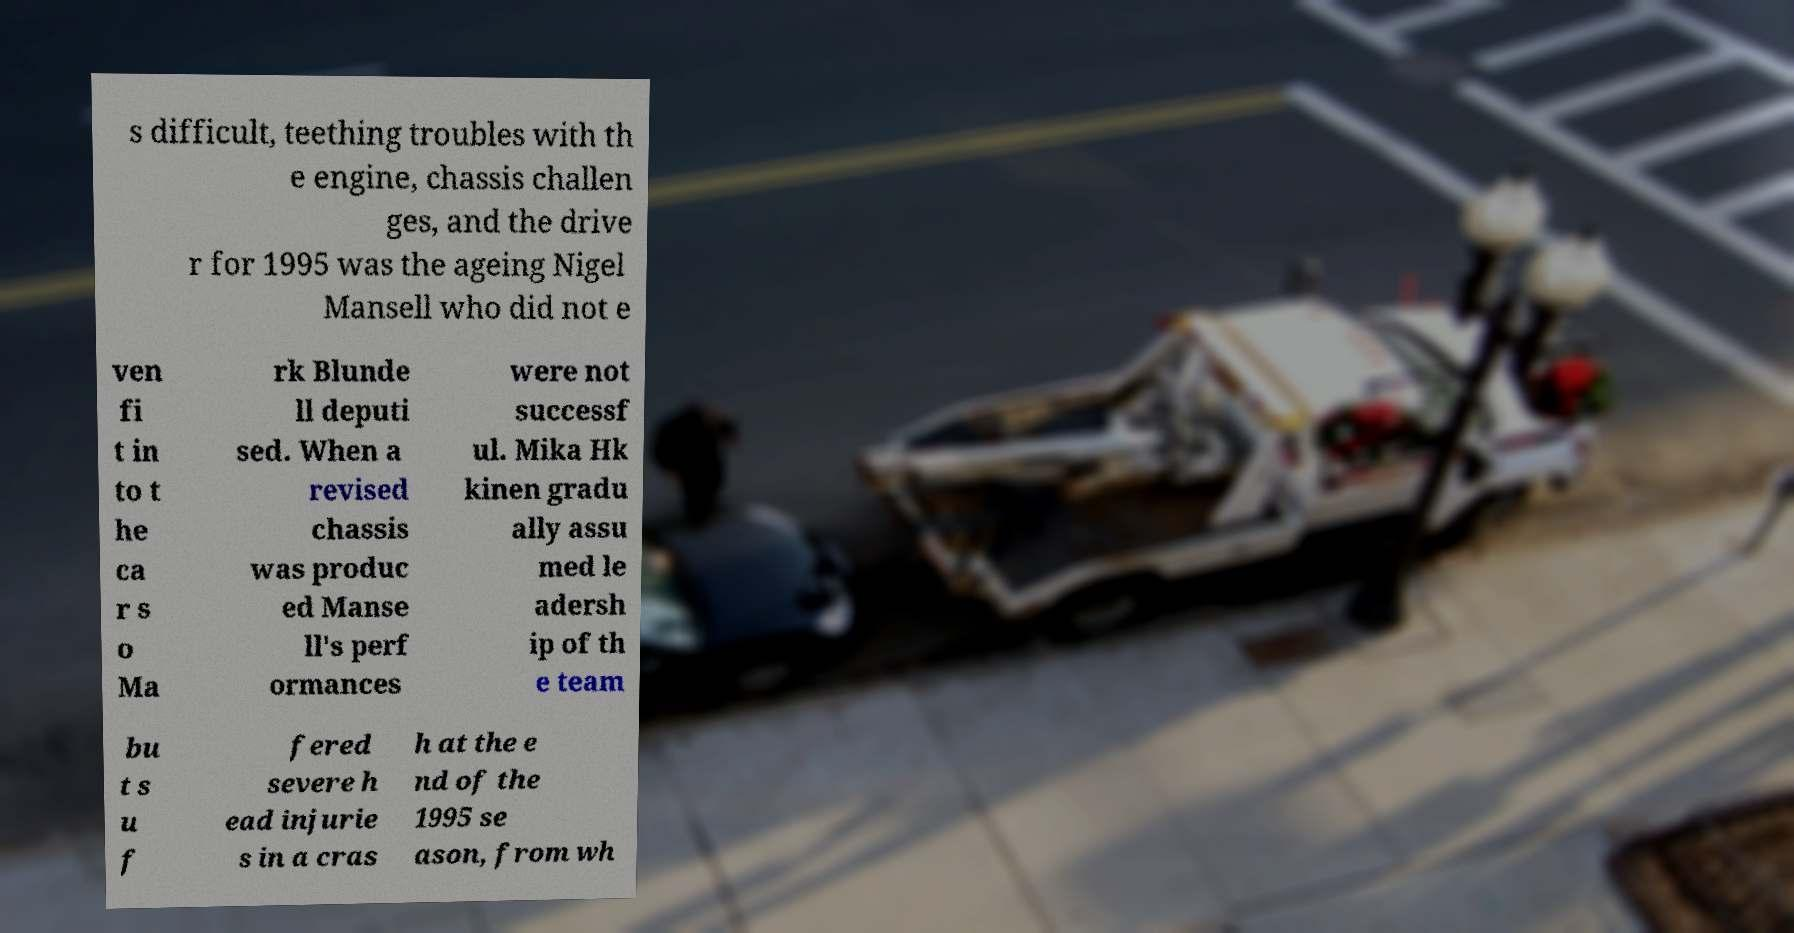Please identify and transcribe the text found in this image. s difficult, teething troubles with th e engine, chassis challen ges, and the drive r for 1995 was the ageing Nigel Mansell who did not e ven fi t in to t he ca r s o Ma rk Blunde ll deputi sed. When a revised chassis was produc ed Manse ll's perf ormances were not successf ul. Mika Hk kinen gradu ally assu med le adersh ip of th e team bu t s u f fered severe h ead injurie s in a cras h at the e nd of the 1995 se ason, from wh 